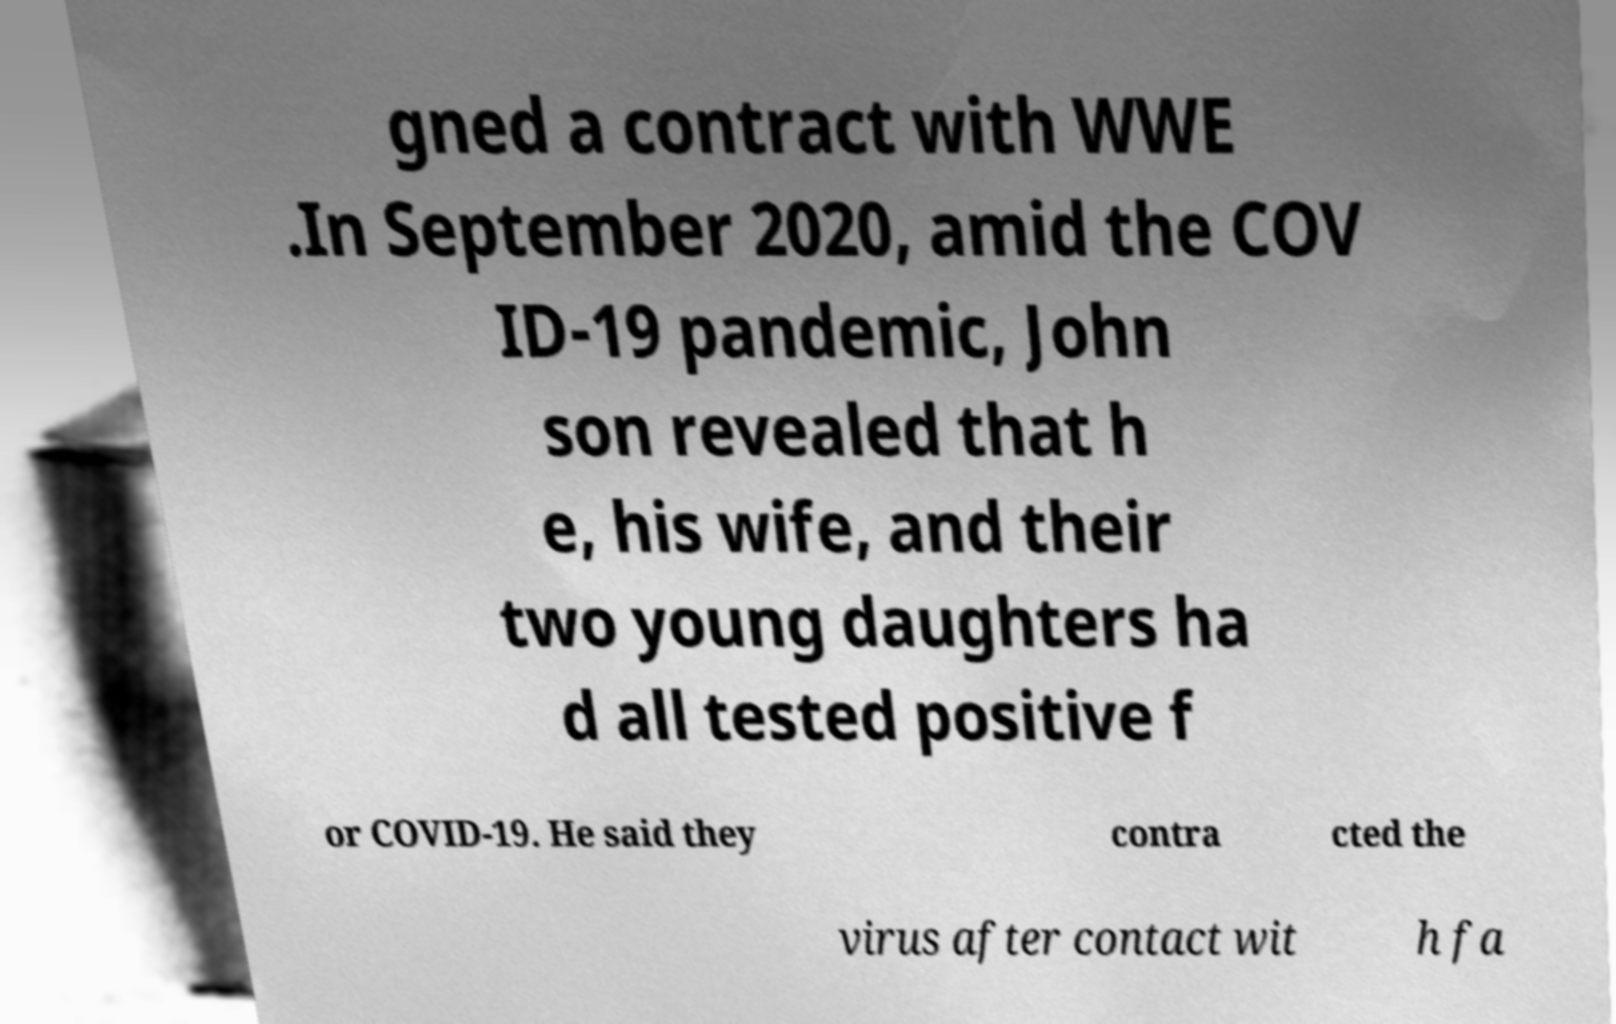Could you extract and type out the text from this image? gned a contract with WWE .In September 2020, amid the COV ID-19 pandemic, John son revealed that h e, his wife, and their two young daughters ha d all tested positive f or COVID-19. He said they contra cted the virus after contact wit h fa 